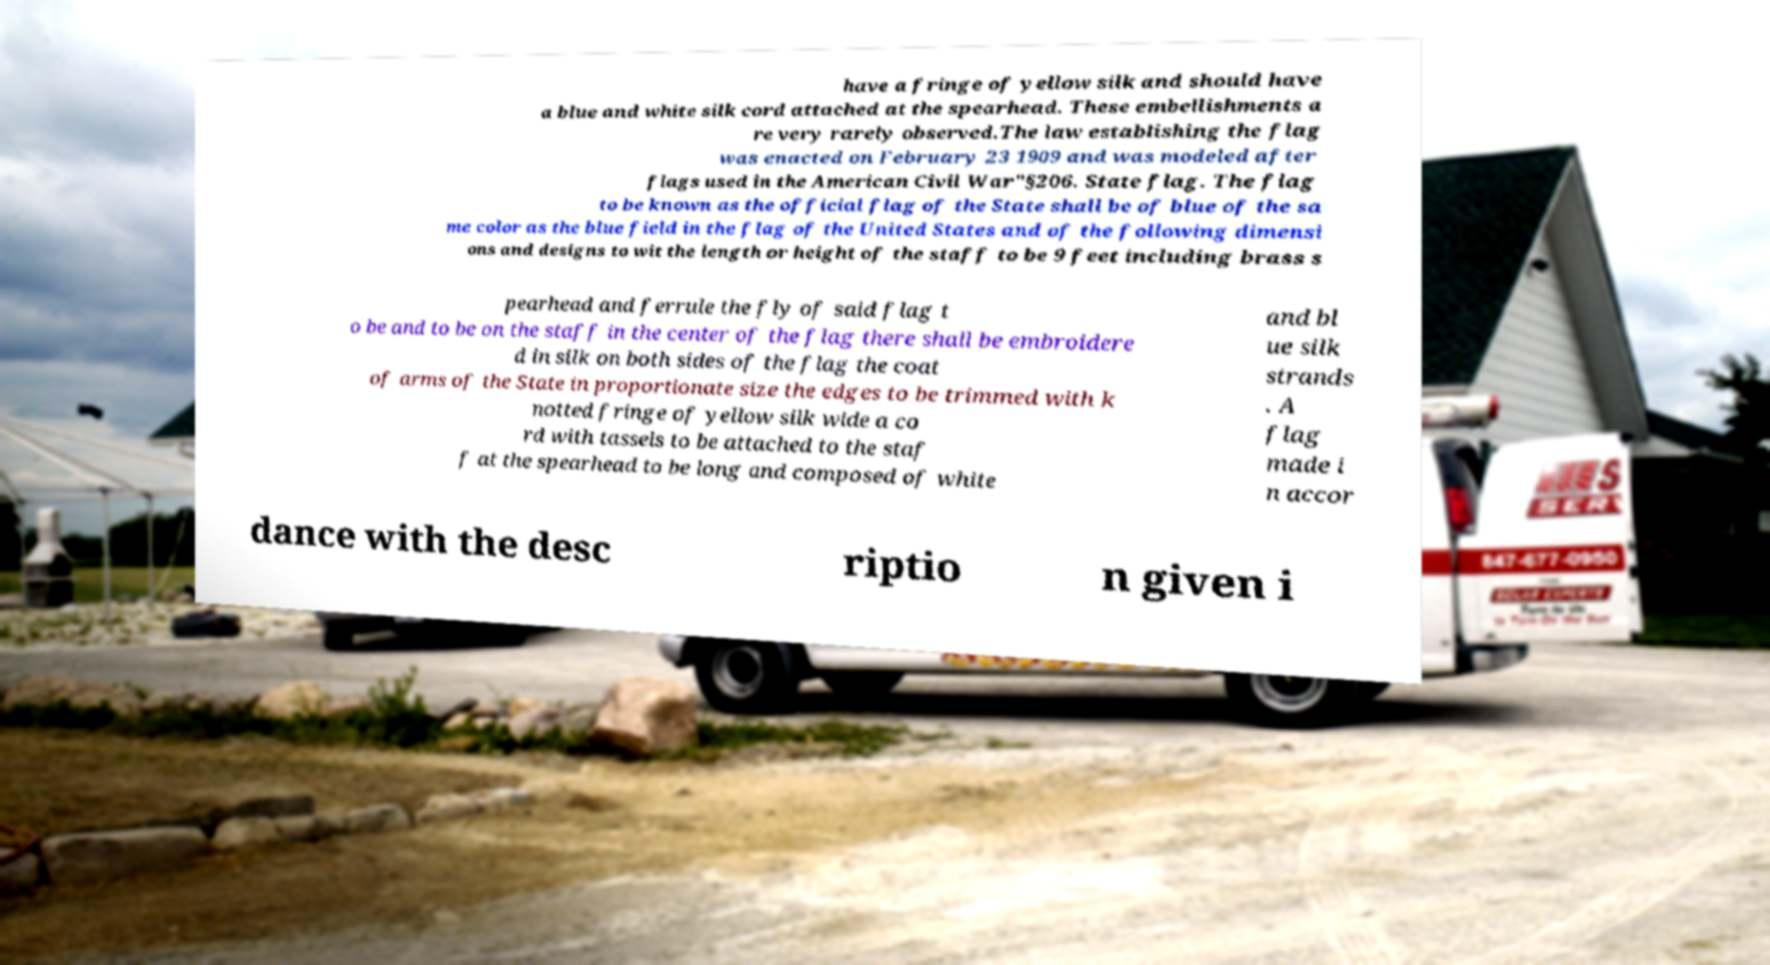Can you read and provide the text displayed in the image?This photo seems to have some interesting text. Can you extract and type it out for me? have a fringe of yellow silk and should have a blue and white silk cord attached at the spearhead. These embellishments a re very rarely observed.The law establishing the flag was enacted on February 23 1909 and was modeled after flags used in the American Civil War"§206. State flag. The flag to be known as the official flag of the State shall be of blue of the sa me color as the blue field in the flag of the United States and of the following dimensi ons and designs to wit the length or height of the staff to be 9 feet including brass s pearhead and ferrule the fly of said flag t o be and to be on the staff in the center of the flag there shall be embroidere d in silk on both sides of the flag the coat of arms of the State in proportionate size the edges to be trimmed with k notted fringe of yellow silk wide a co rd with tassels to be attached to the staf f at the spearhead to be long and composed of white and bl ue silk strands . A flag made i n accor dance with the desc riptio n given i 